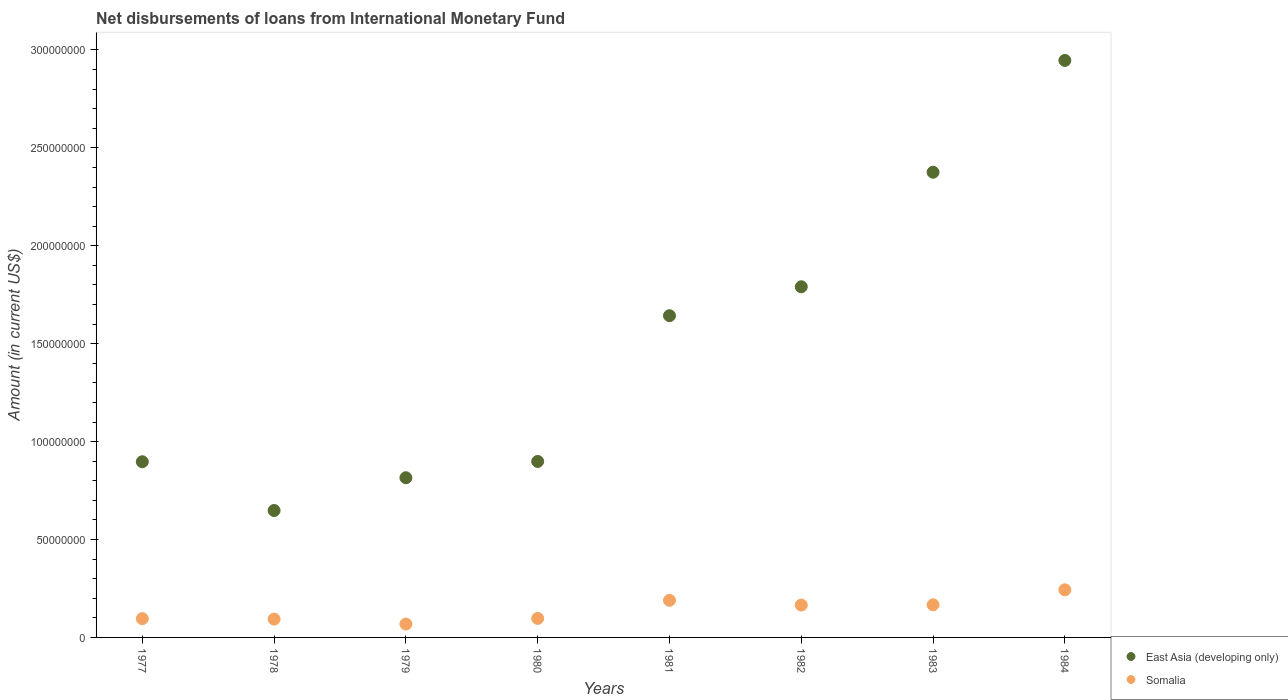How many different coloured dotlines are there?
Your response must be concise. 2. What is the amount of loans disbursed in East Asia (developing only) in 1983?
Offer a terse response. 2.38e+08. Across all years, what is the maximum amount of loans disbursed in Somalia?
Give a very brief answer. 2.43e+07. Across all years, what is the minimum amount of loans disbursed in Somalia?
Provide a succinct answer. 6.83e+06. In which year was the amount of loans disbursed in East Asia (developing only) minimum?
Your answer should be very brief. 1978. What is the total amount of loans disbursed in Somalia in the graph?
Your response must be concise. 1.12e+08. What is the difference between the amount of loans disbursed in Somalia in 1978 and that in 1979?
Offer a very short reply. 2.52e+06. What is the difference between the amount of loans disbursed in Somalia in 1984 and the amount of loans disbursed in East Asia (developing only) in 1979?
Offer a terse response. -5.72e+07. What is the average amount of loans disbursed in Somalia per year?
Offer a very short reply. 1.40e+07. In the year 1982, what is the difference between the amount of loans disbursed in East Asia (developing only) and amount of loans disbursed in Somalia?
Offer a very short reply. 1.63e+08. What is the ratio of the amount of loans disbursed in Somalia in 1983 to that in 1984?
Give a very brief answer. 0.69. Is the amount of loans disbursed in Somalia in 1978 less than that in 1984?
Provide a succinct answer. Yes. Is the difference between the amount of loans disbursed in East Asia (developing only) in 1980 and 1984 greater than the difference between the amount of loans disbursed in Somalia in 1980 and 1984?
Give a very brief answer. No. What is the difference between the highest and the second highest amount of loans disbursed in East Asia (developing only)?
Offer a very short reply. 5.71e+07. What is the difference between the highest and the lowest amount of loans disbursed in Somalia?
Your response must be concise. 1.75e+07. Is the sum of the amount of loans disbursed in Somalia in 1981 and 1983 greater than the maximum amount of loans disbursed in East Asia (developing only) across all years?
Your response must be concise. No. Is the amount of loans disbursed in Somalia strictly greater than the amount of loans disbursed in East Asia (developing only) over the years?
Give a very brief answer. No. Is the amount of loans disbursed in East Asia (developing only) strictly less than the amount of loans disbursed in Somalia over the years?
Make the answer very short. No. How many dotlines are there?
Provide a short and direct response. 2. How many years are there in the graph?
Make the answer very short. 8. What is the difference between two consecutive major ticks on the Y-axis?
Ensure brevity in your answer.  5.00e+07. Does the graph contain any zero values?
Keep it short and to the point. No. Does the graph contain grids?
Your answer should be compact. No. Where does the legend appear in the graph?
Offer a terse response. Bottom right. How many legend labels are there?
Give a very brief answer. 2. What is the title of the graph?
Make the answer very short. Net disbursements of loans from International Monetary Fund. What is the label or title of the X-axis?
Offer a terse response. Years. What is the label or title of the Y-axis?
Keep it short and to the point. Amount (in current US$). What is the Amount (in current US$) in East Asia (developing only) in 1977?
Your response must be concise. 8.97e+07. What is the Amount (in current US$) in Somalia in 1977?
Make the answer very short. 9.60e+06. What is the Amount (in current US$) of East Asia (developing only) in 1978?
Your answer should be compact. 6.48e+07. What is the Amount (in current US$) of Somalia in 1978?
Offer a very short reply. 9.35e+06. What is the Amount (in current US$) of East Asia (developing only) in 1979?
Your response must be concise. 8.15e+07. What is the Amount (in current US$) of Somalia in 1979?
Provide a short and direct response. 6.83e+06. What is the Amount (in current US$) of East Asia (developing only) in 1980?
Provide a succinct answer. 8.99e+07. What is the Amount (in current US$) in Somalia in 1980?
Ensure brevity in your answer.  9.72e+06. What is the Amount (in current US$) in East Asia (developing only) in 1981?
Your response must be concise. 1.64e+08. What is the Amount (in current US$) in Somalia in 1981?
Provide a short and direct response. 1.90e+07. What is the Amount (in current US$) of East Asia (developing only) in 1982?
Your answer should be compact. 1.79e+08. What is the Amount (in current US$) of Somalia in 1982?
Keep it short and to the point. 1.65e+07. What is the Amount (in current US$) in East Asia (developing only) in 1983?
Give a very brief answer. 2.38e+08. What is the Amount (in current US$) of Somalia in 1983?
Provide a short and direct response. 1.67e+07. What is the Amount (in current US$) of East Asia (developing only) in 1984?
Offer a very short reply. 2.95e+08. What is the Amount (in current US$) in Somalia in 1984?
Offer a terse response. 2.43e+07. Across all years, what is the maximum Amount (in current US$) in East Asia (developing only)?
Give a very brief answer. 2.95e+08. Across all years, what is the maximum Amount (in current US$) in Somalia?
Your answer should be very brief. 2.43e+07. Across all years, what is the minimum Amount (in current US$) of East Asia (developing only)?
Your answer should be compact. 6.48e+07. Across all years, what is the minimum Amount (in current US$) in Somalia?
Provide a succinct answer. 6.83e+06. What is the total Amount (in current US$) of East Asia (developing only) in the graph?
Make the answer very short. 1.20e+09. What is the total Amount (in current US$) in Somalia in the graph?
Ensure brevity in your answer.  1.12e+08. What is the difference between the Amount (in current US$) in East Asia (developing only) in 1977 and that in 1978?
Your answer should be very brief. 2.49e+07. What is the difference between the Amount (in current US$) of East Asia (developing only) in 1977 and that in 1979?
Provide a short and direct response. 8.17e+06. What is the difference between the Amount (in current US$) of Somalia in 1977 and that in 1979?
Provide a short and direct response. 2.77e+06. What is the difference between the Amount (in current US$) of East Asia (developing only) in 1977 and that in 1980?
Provide a succinct answer. -1.52e+05. What is the difference between the Amount (in current US$) in Somalia in 1977 and that in 1980?
Offer a terse response. -1.20e+05. What is the difference between the Amount (in current US$) of East Asia (developing only) in 1977 and that in 1981?
Provide a short and direct response. -7.46e+07. What is the difference between the Amount (in current US$) in Somalia in 1977 and that in 1981?
Give a very brief answer. -9.36e+06. What is the difference between the Amount (in current US$) in East Asia (developing only) in 1977 and that in 1982?
Offer a terse response. -8.93e+07. What is the difference between the Amount (in current US$) in Somalia in 1977 and that in 1982?
Offer a very short reply. -6.93e+06. What is the difference between the Amount (in current US$) of East Asia (developing only) in 1977 and that in 1983?
Provide a short and direct response. -1.48e+08. What is the difference between the Amount (in current US$) of Somalia in 1977 and that in 1983?
Your answer should be very brief. -7.06e+06. What is the difference between the Amount (in current US$) in East Asia (developing only) in 1977 and that in 1984?
Keep it short and to the point. -2.05e+08. What is the difference between the Amount (in current US$) of Somalia in 1977 and that in 1984?
Offer a terse response. -1.47e+07. What is the difference between the Amount (in current US$) of East Asia (developing only) in 1978 and that in 1979?
Your answer should be very brief. -1.67e+07. What is the difference between the Amount (in current US$) in Somalia in 1978 and that in 1979?
Ensure brevity in your answer.  2.52e+06. What is the difference between the Amount (in current US$) in East Asia (developing only) in 1978 and that in 1980?
Keep it short and to the point. -2.50e+07. What is the difference between the Amount (in current US$) in Somalia in 1978 and that in 1980?
Offer a very short reply. -3.70e+05. What is the difference between the Amount (in current US$) of East Asia (developing only) in 1978 and that in 1981?
Your response must be concise. -9.95e+07. What is the difference between the Amount (in current US$) of Somalia in 1978 and that in 1981?
Provide a short and direct response. -9.61e+06. What is the difference between the Amount (in current US$) in East Asia (developing only) in 1978 and that in 1982?
Give a very brief answer. -1.14e+08. What is the difference between the Amount (in current US$) in Somalia in 1978 and that in 1982?
Offer a terse response. -7.18e+06. What is the difference between the Amount (in current US$) of East Asia (developing only) in 1978 and that in 1983?
Provide a short and direct response. -1.73e+08. What is the difference between the Amount (in current US$) in Somalia in 1978 and that in 1983?
Your answer should be compact. -7.32e+06. What is the difference between the Amount (in current US$) of East Asia (developing only) in 1978 and that in 1984?
Provide a short and direct response. -2.30e+08. What is the difference between the Amount (in current US$) in Somalia in 1978 and that in 1984?
Provide a short and direct response. -1.50e+07. What is the difference between the Amount (in current US$) of East Asia (developing only) in 1979 and that in 1980?
Offer a very short reply. -8.32e+06. What is the difference between the Amount (in current US$) in Somalia in 1979 and that in 1980?
Keep it short and to the point. -2.89e+06. What is the difference between the Amount (in current US$) in East Asia (developing only) in 1979 and that in 1981?
Provide a short and direct response. -8.28e+07. What is the difference between the Amount (in current US$) in Somalia in 1979 and that in 1981?
Offer a terse response. -1.21e+07. What is the difference between the Amount (in current US$) in East Asia (developing only) in 1979 and that in 1982?
Make the answer very short. -9.75e+07. What is the difference between the Amount (in current US$) of Somalia in 1979 and that in 1982?
Your answer should be very brief. -9.70e+06. What is the difference between the Amount (in current US$) of East Asia (developing only) in 1979 and that in 1983?
Your answer should be compact. -1.56e+08. What is the difference between the Amount (in current US$) of Somalia in 1979 and that in 1983?
Keep it short and to the point. -9.84e+06. What is the difference between the Amount (in current US$) of East Asia (developing only) in 1979 and that in 1984?
Make the answer very short. -2.13e+08. What is the difference between the Amount (in current US$) in Somalia in 1979 and that in 1984?
Offer a very short reply. -1.75e+07. What is the difference between the Amount (in current US$) in East Asia (developing only) in 1980 and that in 1981?
Keep it short and to the point. -7.44e+07. What is the difference between the Amount (in current US$) in Somalia in 1980 and that in 1981?
Provide a succinct answer. -9.24e+06. What is the difference between the Amount (in current US$) in East Asia (developing only) in 1980 and that in 1982?
Provide a succinct answer. -8.92e+07. What is the difference between the Amount (in current US$) of Somalia in 1980 and that in 1982?
Your response must be concise. -6.81e+06. What is the difference between the Amount (in current US$) of East Asia (developing only) in 1980 and that in 1983?
Ensure brevity in your answer.  -1.48e+08. What is the difference between the Amount (in current US$) of Somalia in 1980 and that in 1983?
Your answer should be very brief. -6.94e+06. What is the difference between the Amount (in current US$) of East Asia (developing only) in 1980 and that in 1984?
Ensure brevity in your answer.  -2.05e+08. What is the difference between the Amount (in current US$) of Somalia in 1980 and that in 1984?
Ensure brevity in your answer.  -1.46e+07. What is the difference between the Amount (in current US$) in East Asia (developing only) in 1981 and that in 1982?
Keep it short and to the point. -1.48e+07. What is the difference between the Amount (in current US$) of Somalia in 1981 and that in 1982?
Provide a short and direct response. 2.43e+06. What is the difference between the Amount (in current US$) of East Asia (developing only) in 1981 and that in 1983?
Offer a terse response. -7.33e+07. What is the difference between the Amount (in current US$) of Somalia in 1981 and that in 1983?
Give a very brief answer. 2.29e+06. What is the difference between the Amount (in current US$) in East Asia (developing only) in 1981 and that in 1984?
Provide a short and direct response. -1.30e+08. What is the difference between the Amount (in current US$) of Somalia in 1981 and that in 1984?
Offer a very short reply. -5.37e+06. What is the difference between the Amount (in current US$) in East Asia (developing only) in 1982 and that in 1983?
Offer a terse response. -5.85e+07. What is the difference between the Amount (in current US$) of Somalia in 1982 and that in 1983?
Make the answer very short. -1.35e+05. What is the difference between the Amount (in current US$) in East Asia (developing only) in 1982 and that in 1984?
Provide a succinct answer. -1.16e+08. What is the difference between the Amount (in current US$) of Somalia in 1982 and that in 1984?
Your answer should be compact. -7.80e+06. What is the difference between the Amount (in current US$) of East Asia (developing only) in 1983 and that in 1984?
Give a very brief answer. -5.71e+07. What is the difference between the Amount (in current US$) of Somalia in 1983 and that in 1984?
Provide a succinct answer. -7.66e+06. What is the difference between the Amount (in current US$) of East Asia (developing only) in 1977 and the Amount (in current US$) of Somalia in 1978?
Provide a short and direct response. 8.04e+07. What is the difference between the Amount (in current US$) in East Asia (developing only) in 1977 and the Amount (in current US$) in Somalia in 1979?
Offer a terse response. 8.29e+07. What is the difference between the Amount (in current US$) in East Asia (developing only) in 1977 and the Amount (in current US$) in Somalia in 1980?
Offer a very short reply. 8.00e+07. What is the difference between the Amount (in current US$) in East Asia (developing only) in 1977 and the Amount (in current US$) in Somalia in 1981?
Ensure brevity in your answer.  7.08e+07. What is the difference between the Amount (in current US$) in East Asia (developing only) in 1977 and the Amount (in current US$) in Somalia in 1982?
Your answer should be compact. 7.32e+07. What is the difference between the Amount (in current US$) of East Asia (developing only) in 1977 and the Amount (in current US$) of Somalia in 1983?
Ensure brevity in your answer.  7.30e+07. What is the difference between the Amount (in current US$) of East Asia (developing only) in 1977 and the Amount (in current US$) of Somalia in 1984?
Make the answer very short. 6.54e+07. What is the difference between the Amount (in current US$) in East Asia (developing only) in 1978 and the Amount (in current US$) in Somalia in 1979?
Offer a very short reply. 5.80e+07. What is the difference between the Amount (in current US$) in East Asia (developing only) in 1978 and the Amount (in current US$) in Somalia in 1980?
Make the answer very short. 5.51e+07. What is the difference between the Amount (in current US$) of East Asia (developing only) in 1978 and the Amount (in current US$) of Somalia in 1981?
Make the answer very short. 4.59e+07. What is the difference between the Amount (in current US$) in East Asia (developing only) in 1978 and the Amount (in current US$) in Somalia in 1982?
Offer a terse response. 4.83e+07. What is the difference between the Amount (in current US$) of East Asia (developing only) in 1978 and the Amount (in current US$) of Somalia in 1983?
Your answer should be compact. 4.82e+07. What is the difference between the Amount (in current US$) in East Asia (developing only) in 1978 and the Amount (in current US$) in Somalia in 1984?
Offer a terse response. 4.05e+07. What is the difference between the Amount (in current US$) in East Asia (developing only) in 1979 and the Amount (in current US$) in Somalia in 1980?
Your response must be concise. 7.18e+07. What is the difference between the Amount (in current US$) of East Asia (developing only) in 1979 and the Amount (in current US$) of Somalia in 1981?
Your answer should be very brief. 6.26e+07. What is the difference between the Amount (in current US$) in East Asia (developing only) in 1979 and the Amount (in current US$) in Somalia in 1982?
Offer a very short reply. 6.50e+07. What is the difference between the Amount (in current US$) in East Asia (developing only) in 1979 and the Amount (in current US$) in Somalia in 1983?
Ensure brevity in your answer.  6.49e+07. What is the difference between the Amount (in current US$) in East Asia (developing only) in 1979 and the Amount (in current US$) in Somalia in 1984?
Provide a succinct answer. 5.72e+07. What is the difference between the Amount (in current US$) in East Asia (developing only) in 1980 and the Amount (in current US$) in Somalia in 1981?
Provide a succinct answer. 7.09e+07. What is the difference between the Amount (in current US$) in East Asia (developing only) in 1980 and the Amount (in current US$) in Somalia in 1982?
Provide a succinct answer. 7.33e+07. What is the difference between the Amount (in current US$) of East Asia (developing only) in 1980 and the Amount (in current US$) of Somalia in 1983?
Keep it short and to the point. 7.32e+07. What is the difference between the Amount (in current US$) of East Asia (developing only) in 1980 and the Amount (in current US$) of Somalia in 1984?
Give a very brief answer. 6.55e+07. What is the difference between the Amount (in current US$) in East Asia (developing only) in 1981 and the Amount (in current US$) in Somalia in 1982?
Make the answer very short. 1.48e+08. What is the difference between the Amount (in current US$) in East Asia (developing only) in 1981 and the Amount (in current US$) in Somalia in 1983?
Keep it short and to the point. 1.48e+08. What is the difference between the Amount (in current US$) in East Asia (developing only) in 1981 and the Amount (in current US$) in Somalia in 1984?
Provide a succinct answer. 1.40e+08. What is the difference between the Amount (in current US$) in East Asia (developing only) in 1982 and the Amount (in current US$) in Somalia in 1983?
Offer a very short reply. 1.62e+08. What is the difference between the Amount (in current US$) of East Asia (developing only) in 1982 and the Amount (in current US$) of Somalia in 1984?
Provide a short and direct response. 1.55e+08. What is the difference between the Amount (in current US$) of East Asia (developing only) in 1983 and the Amount (in current US$) of Somalia in 1984?
Your answer should be very brief. 2.13e+08. What is the average Amount (in current US$) in East Asia (developing only) per year?
Keep it short and to the point. 1.50e+08. What is the average Amount (in current US$) of Somalia per year?
Provide a succinct answer. 1.40e+07. In the year 1977, what is the difference between the Amount (in current US$) in East Asia (developing only) and Amount (in current US$) in Somalia?
Provide a succinct answer. 8.01e+07. In the year 1978, what is the difference between the Amount (in current US$) of East Asia (developing only) and Amount (in current US$) of Somalia?
Make the answer very short. 5.55e+07. In the year 1979, what is the difference between the Amount (in current US$) of East Asia (developing only) and Amount (in current US$) of Somalia?
Ensure brevity in your answer.  7.47e+07. In the year 1980, what is the difference between the Amount (in current US$) in East Asia (developing only) and Amount (in current US$) in Somalia?
Offer a very short reply. 8.01e+07. In the year 1981, what is the difference between the Amount (in current US$) in East Asia (developing only) and Amount (in current US$) in Somalia?
Offer a terse response. 1.45e+08. In the year 1982, what is the difference between the Amount (in current US$) in East Asia (developing only) and Amount (in current US$) in Somalia?
Provide a succinct answer. 1.63e+08. In the year 1983, what is the difference between the Amount (in current US$) of East Asia (developing only) and Amount (in current US$) of Somalia?
Offer a very short reply. 2.21e+08. In the year 1984, what is the difference between the Amount (in current US$) of East Asia (developing only) and Amount (in current US$) of Somalia?
Offer a very short reply. 2.70e+08. What is the ratio of the Amount (in current US$) in East Asia (developing only) in 1977 to that in 1978?
Give a very brief answer. 1.38. What is the ratio of the Amount (in current US$) of Somalia in 1977 to that in 1978?
Your answer should be compact. 1.03. What is the ratio of the Amount (in current US$) of East Asia (developing only) in 1977 to that in 1979?
Make the answer very short. 1.1. What is the ratio of the Amount (in current US$) in Somalia in 1977 to that in 1979?
Ensure brevity in your answer.  1.41. What is the ratio of the Amount (in current US$) in East Asia (developing only) in 1977 to that in 1980?
Give a very brief answer. 1. What is the ratio of the Amount (in current US$) in Somalia in 1977 to that in 1980?
Offer a terse response. 0.99. What is the ratio of the Amount (in current US$) of East Asia (developing only) in 1977 to that in 1981?
Provide a succinct answer. 0.55. What is the ratio of the Amount (in current US$) in Somalia in 1977 to that in 1981?
Give a very brief answer. 0.51. What is the ratio of the Amount (in current US$) in East Asia (developing only) in 1977 to that in 1982?
Offer a very short reply. 0.5. What is the ratio of the Amount (in current US$) of Somalia in 1977 to that in 1982?
Your answer should be very brief. 0.58. What is the ratio of the Amount (in current US$) in East Asia (developing only) in 1977 to that in 1983?
Provide a short and direct response. 0.38. What is the ratio of the Amount (in current US$) in Somalia in 1977 to that in 1983?
Provide a succinct answer. 0.58. What is the ratio of the Amount (in current US$) in East Asia (developing only) in 1977 to that in 1984?
Offer a very short reply. 0.3. What is the ratio of the Amount (in current US$) of Somalia in 1977 to that in 1984?
Ensure brevity in your answer.  0.39. What is the ratio of the Amount (in current US$) of East Asia (developing only) in 1978 to that in 1979?
Keep it short and to the point. 0.79. What is the ratio of the Amount (in current US$) in Somalia in 1978 to that in 1979?
Provide a short and direct response. 1.37. What is the ratio of the Amount (in current US$) of East Asia (developing only) in 1978 to that in 1980?
Provide a short and direct response. 0.72. What is the ratio of the Amount (in current US$) in Somalia in 1978 to that in 1980?
Your response must be concise. 0.96. What is the ratio of the Amount (in current US$) of East Asia (developing only) in 1978 to that in 1981?
Your answer should be very brief. 0.39. What is the ratio of the Amount (in current US$) in Somalia in 1978 to that in 1981?
Keep it short and to the point. 0.49. What is the ratio of the Amount (in current US$) of East Asia (developing only) in 1978 to that in 1982?
Offer a terse response. 0.36. What is the ratio of the Amount (in current US$) in Somalia in 1978 to that in 1982?
Your response must be concise. 0.57. What is the ratio of the Amount (in current US$) in East Asia (developing only) in 1978 to that in 1983?
Make the answer very short. 0.27. What is the ratio of the Amount (in current US$) of Somalia in 1978 to that in 1983?
Your answer should be compact. 0.56. What is the ratio of the Amount (in current US$) of East Asia (developing only) in 1978 to that in 1984?
Provide a short and direct response. 0.22. What is the ratio of the Amount (in current US$) of Somalia in 1978 to that in 1984?
Provide a succinct answer. 0.38. What is the ratio of the Amount (in current US$) in East Asia (developing only) in 1979 to that in 1980?
Offer a terse response. 0.91. What is the ratio of the Amount (in current US$) of Somalia in 1979 to that in 1980?
Your response must be concise. 0.7. What is the ratio of the Amount (in current US$) in East Asia (developing only) in 1979 to that in 1981?
Ensure brevity in your answer.  0.5. What is the ratio of the Amount (in current US$) of Somalia in 1979 to that in 1981?
Provide a succinct answer. 0.36. What is the ratio of the Amount (in current US$) of East Asia (developing only) in 1979 to that in 1982?
Make the answer very short. 0.46. What is the ratio of the Amount (in current US$) of Somalia in 1979 to that in 1982?
Keep it short and to the point. 0.41. What is the ratio of the Amount (in current US$) in East Asia (developing only) in 1979 to that in 1983?
Offer a terse response. 0.34. What is the ratio of the Amount (in current US$) of Somalia in 1979 to that in 1983?
Give a very brief answer. 0.41. What is the ratio of the Amount (in current US$) of East Asia (developing only) in 1979 to that in 1984?
Your response must be concise. 0.28. What is the ratio of the Amount (in current US$) in Somalia in 1979 to that in 1984?
Give a very brief answer. 0.28. What is the ratio of the Amount (in current US$) of East Asia (developing only) in 1980 to that in 1981?
Offer a terse response. 0.55. What is the ratio of the Amount (in current US$) in Somalia in 1980 to that in 1981?
Offer a terse response. 0.51. What is the ratio of the Amount (in current US$) in East Asia (developing only) in 1980 to that in 1982?
Provide a short and direct response. 0.5. What is the ratio of the Amount (in current US$) in Somalia in 1980 to that in 1982?
Your answer should be compact. 0.59. What is the ratio of the Amount (in current US$) in East Asia (developing only) in 1980 to that in 1983?
Keep it short and to the point. 0.38. What is the ratio of the Amount (in current US$) in Somalia in 1980 to that in 1983?
Provide a short and direct response. 0.58. What is the ratio of the Amount (in current US$) in East Asia (developing only) in 1980 to that in 1984?
Ensure brevity in your answer.  0.3. What is the ratio of the Amount (in current US$) of Somalia in 1980 to that in 1984?
Offer a very short reply. 0.4. What is the ratio of the Amount (in current US$) of East Asia (developing only) in 1981 to that in 1982?
Make the answer very short. 0.92. What is the ratio of the Amount (in current US$) of Somalia in 1981 to that in 1982?
Your answer should be compact. 1.15. What is the ratio of the Amount (in current US$) of East Asia (developing only) in 1981 to that in 1983?
Your response must be concise. 0.69. What is the ratio of the Amount (in current US$) of Somalia in 1981 to that in 1983?
Keep it short and to the point. 1.14. What is the ratio of the Amount (in current US$) of East Asia (developing only) in 1981 to that in 1984?
Make the answer very short. 0.56. What is the ratio of the Amount (in current US$) of Somalia in 1981 to that in 1984?
Make the answer very short. 0.78. What is the ratio of the Amount (in current US$) of East Asia (developing only) in 1982 to that in 1983?
Provide a short and direct response. 0.75. What is the ratio of the Amount (in current US$) in Somalia in 1982 to that in 1983?
Ensure brevity in your answer.  0.99. What is the ratio of the Amount (in current US$) of East Asia (developing only) in 1982 to that in 1984?
Keep it short and to the point. 0.61. What is the ratio of the Amount (in current US$) of Somalia in 1982 to that in 1984?
Your answer should be compact. 0.68. What is the ratio of the Amount (in current US$) in East Asia (developing only) in 1983 to that in 1984?
Ensure brevity in your answer.  0.81. What is the ratio of the Amount (in current US$) of Somalia in 1983 to that in 1984?
Your answer should be compact. 0.69. What is the difference between the highest and the second highest Amount (in current US$) in East Asia (developing only)?
Your answer should be compact. 5.71e+07. What is the difference between the highest and the second highest Amount (in current US$) in Somalia?
Your response must be concise. 5.37e+06. What is the difference between the highest and the lowest Amount (in current US$) of East Asia (developing only)?
Offer a very short reply. 2.30e+08. What is the difference between the highest and the lowest Amount (in current US$) in Somalia?
Your response must be concise. 1.75e+07. 